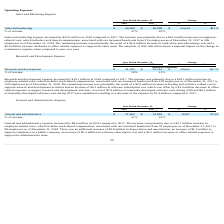According to Everbridge's financial document, What was the increase in the Sales and marketing expense in 2018 compared to 2017? According to the financial document, $22.6 million. The relevant text states: "Sales and marketing expense increased by $22.6 million in 2018 compared to 2017. The increase was primarily due to a $20.0 million increase in employee- re..." Also, What was the Sales and marketing expense in 2018 and 2017? The document shows two values: 69,608 and 46,998. From the document: "Sales and marketing $ 69,608 $ 46,998 $ 22,610 48.1% Sales and marketing $ 69,608 $ 46,998 $ 22,610 48.1%..." Also, What is the % change in the sales and marketing expense between 2017 and 2018? According to the financial document, 48.1 (percentage). The relevant text states: "Sales and marketing $ 69,608 $ 46,998 $ 22,610 48.1%..." Also, can you calculate: What is the average Sales and marketing expense for 2017 and 2018? To answer this question, I need to perform calculations using the financial data. The calculation is: (69,608 + 46,998) / 2, which equals 58303 (in thousands). This is based on the information: "Sales and marketing $ 69,608 $ 46,998 $ 22,610 48.1% Sales and marketing $ 69,608 $ 46,998 $ 22,610 48.1%..." The key data points involved are: 46,998, 69,608. Additionally, In which year was Sales and marketing expenses less than 50,000 thousands? According to the financial document, 2017. The relevant text states: "2018 2017 $ %..." Also, can you calculate: What is the change in the gross margin between 2017 and 2018? Based on the calculation: 47 - 45, the result is 2 (in thousands). This is based on the information: "% of revenue 47% 45% % of revenue 47% 45%..." The key data points involved are: 45, 47. 